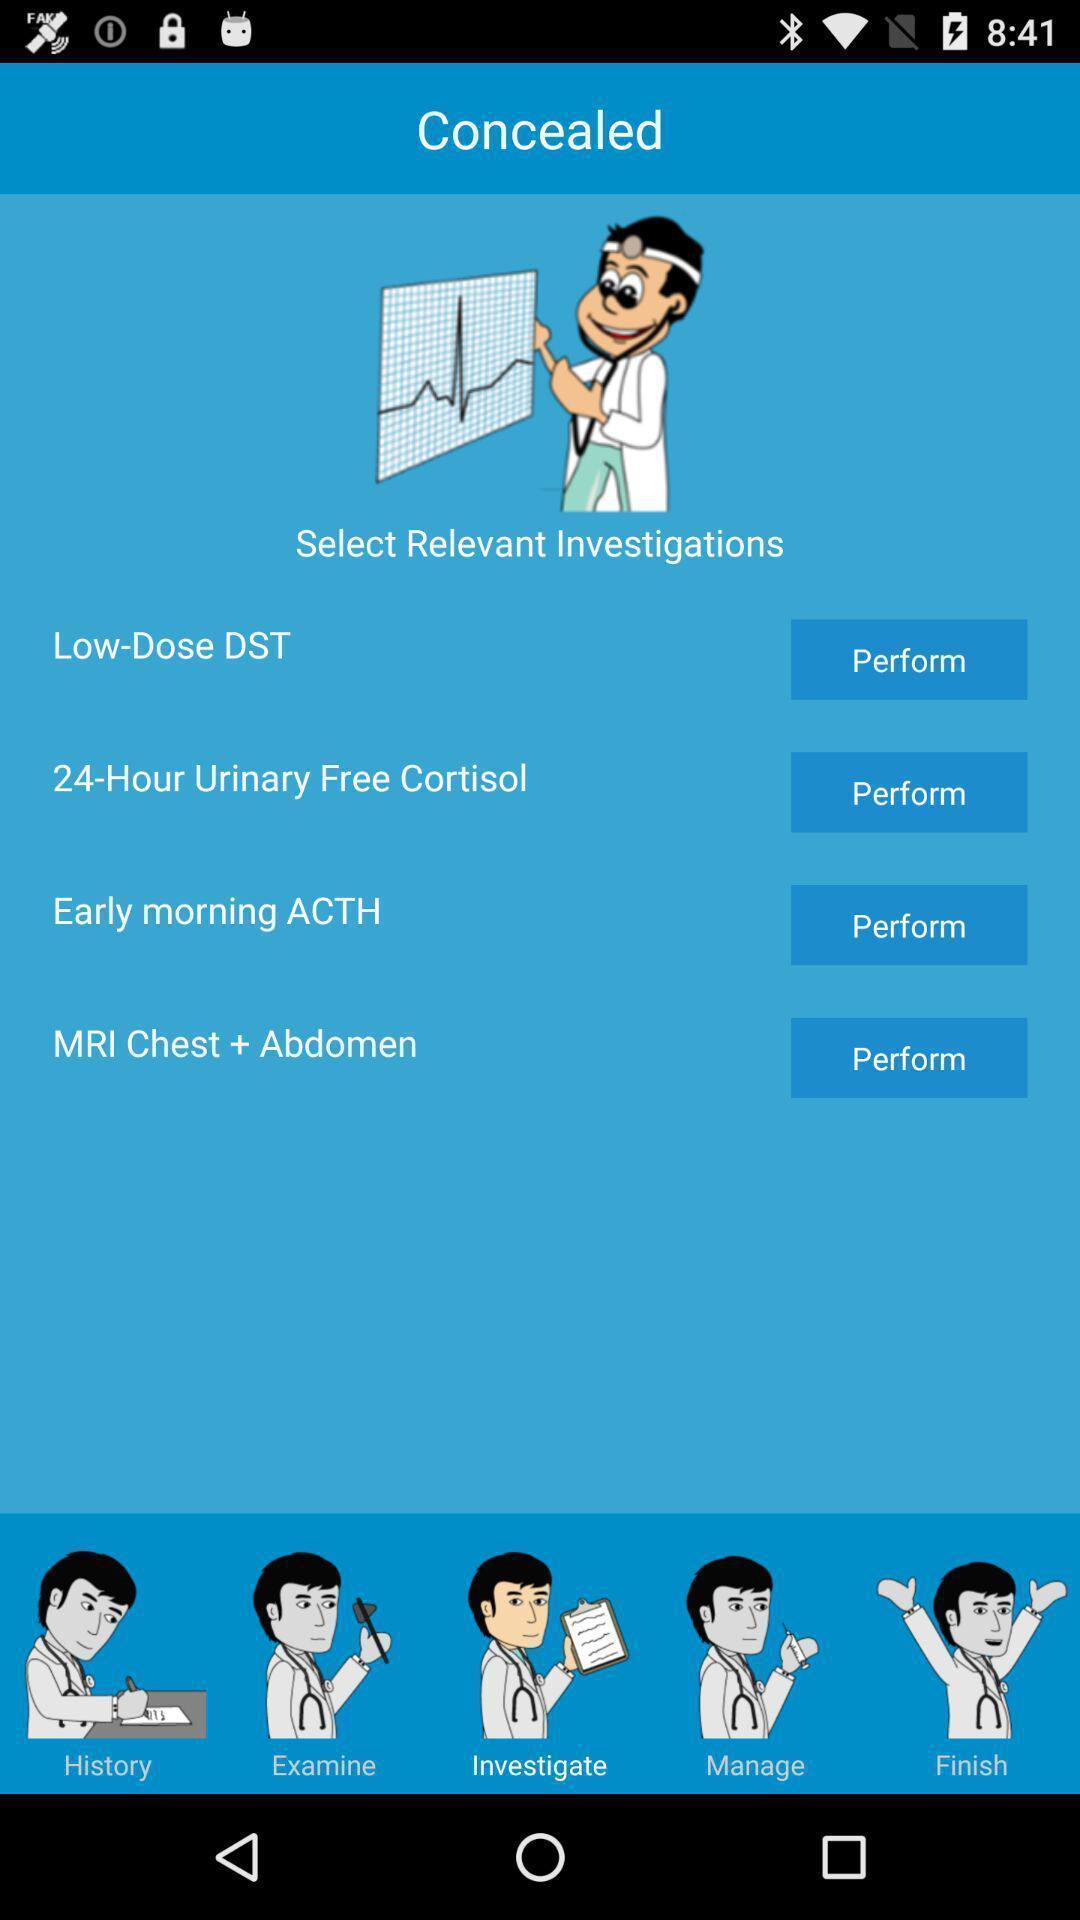Explain what's happening in this screen capture. Screen shows different options. 